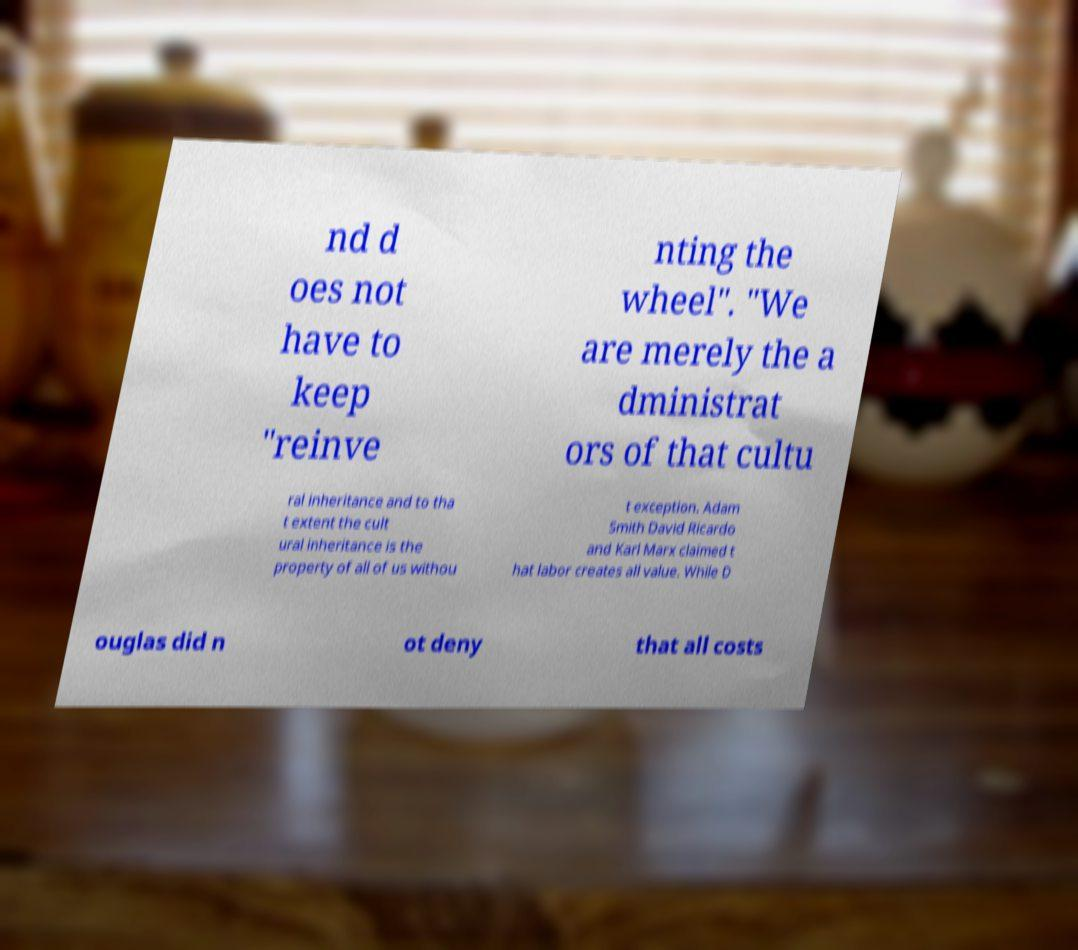Could you assist in decoding the text presented in this image and type it out clearly? nd d oes not have to keep "reinve nting the wheel". "We are merely the a dministrat ors of that cultu ral inheritance and to tha t extent the cult ural inheritance is the property of all of us withou t exception. Adam Smith David Ricardo and Karl Marx claimed t hat labor creates all value. While D ouglas did n ot deny that all costs 